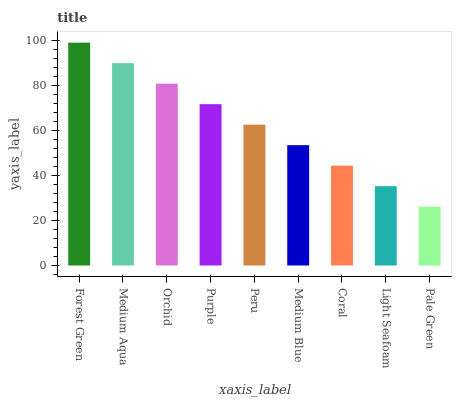Is Pale Green the minimum?
Answer yes or no. Yes. Is Forest Green the maximum?
Answer yes or no. Yes. Is Medium Aqua the minimum?
Answer yes or no. No. Is Medium Aqua the maximum?
Answer yes or no. No. Is Forest Green greater than Medium Aqua?
Answer yes or no. Yes. Is Medium Aqua less than Forest Green?
Answer yes or no. Yes. Is Medium Aqua greater than Forest Green?
Answer yes or no. No. Is Forest Green less than Medium Aqua?
Answer yes or no. No. Is Peru the high median?
Answer yes or no. Yes. Is Peru the low median?
Answer yes or no. Yes. Is Pale Green the high median?
Answer yes or no. No. Is Pale Green the low median?
Answer yes or no. No. 